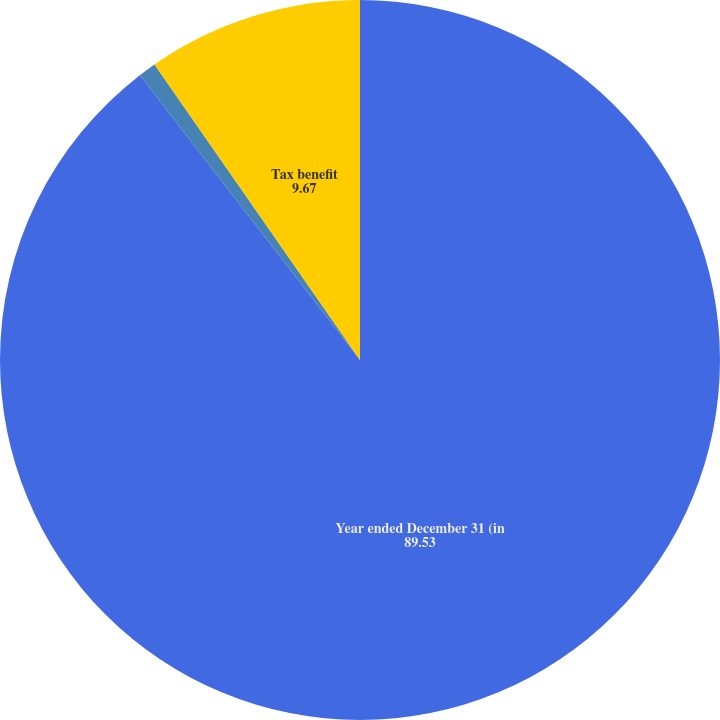<chart> <loc_0><loc_0><loc_500><loc_500><pie_chart><fcel>Year ended December 31 (in<fcel>Cash received for options<fcel>Tax benefit<nl><fcel>89.53%<fcel>0.8%<fcel>9.67%<nl></chart> 